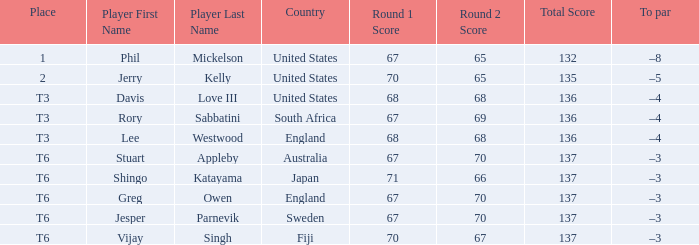Name the score for fiji 70-67=137. Parse the full table. {'header': ['Place', 'Player First Name', 'Player Last Name', 'Country', 'Round 1 Score', 'Round 2 Score', 'Total Score', 'To par'], 'rows': [['1', 'Phil', 'Mickelson', 'United States', '67', '65', '132', '–8'], ['2', 'Jerry', 'Kelly', 'United States', '70', '65', '135', '–5'], ['T3', 'Davis', 'Love III', 'United States', '68', '68', '136', '–4'], ['T3', 'Rory', 'Sabbatini', 'South Africa', '67', '69', '136', '–4'], ['T3', 'Lee', 'Westwood', 'England', '68', '68', '136', '–4'], ['T6', 'Stuart', 'Appleby', 'Australia', '67', '70', '137', '–3'], ['T6', 'Shingo', 'Katayama', 'Japan', '71', '66', '137', '–3'], ['T6', 'Greg', 'Owen', 'England', '67', '70', '137', '–3'], ['T6', 'Jesper', 'Parnevik', 'Sweden', '67', '70', '137', '–3'], ['T6', 'Vijay', 'Singh', 'Fiji', '70', '67', '137', '–3']]} 